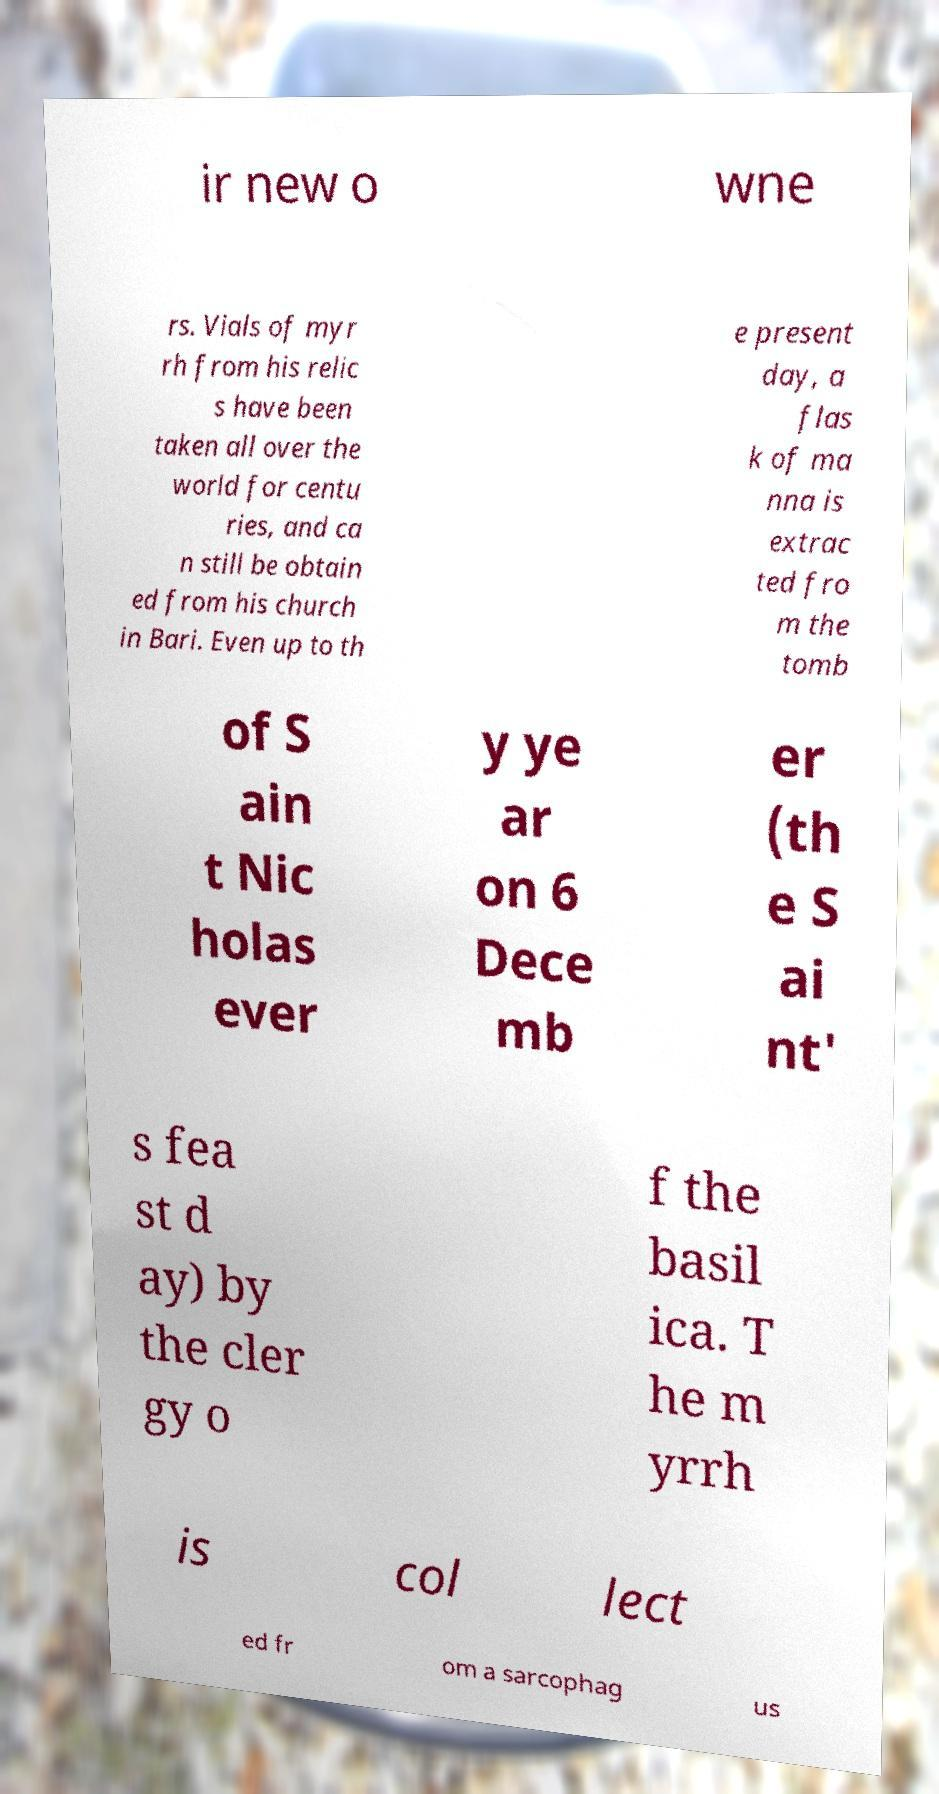I need the written content from this picture converted into text. Can you do that? ir new o wne rs. Vials of myr rh from his relic s have been taken all over the world for centu ries, and ca n still be obtain ed from his church in Bari. Even up to th e present day, a flas k of ma nna is extrac ted fro m the tomb of S ain t Nic holas ever y ye ar on 6 Dece mb er (th e S ai nt' s fea st d ay) by the cler gy o f the basil ica. T he m yrrh is col lect ed fr om a sarcophag us 